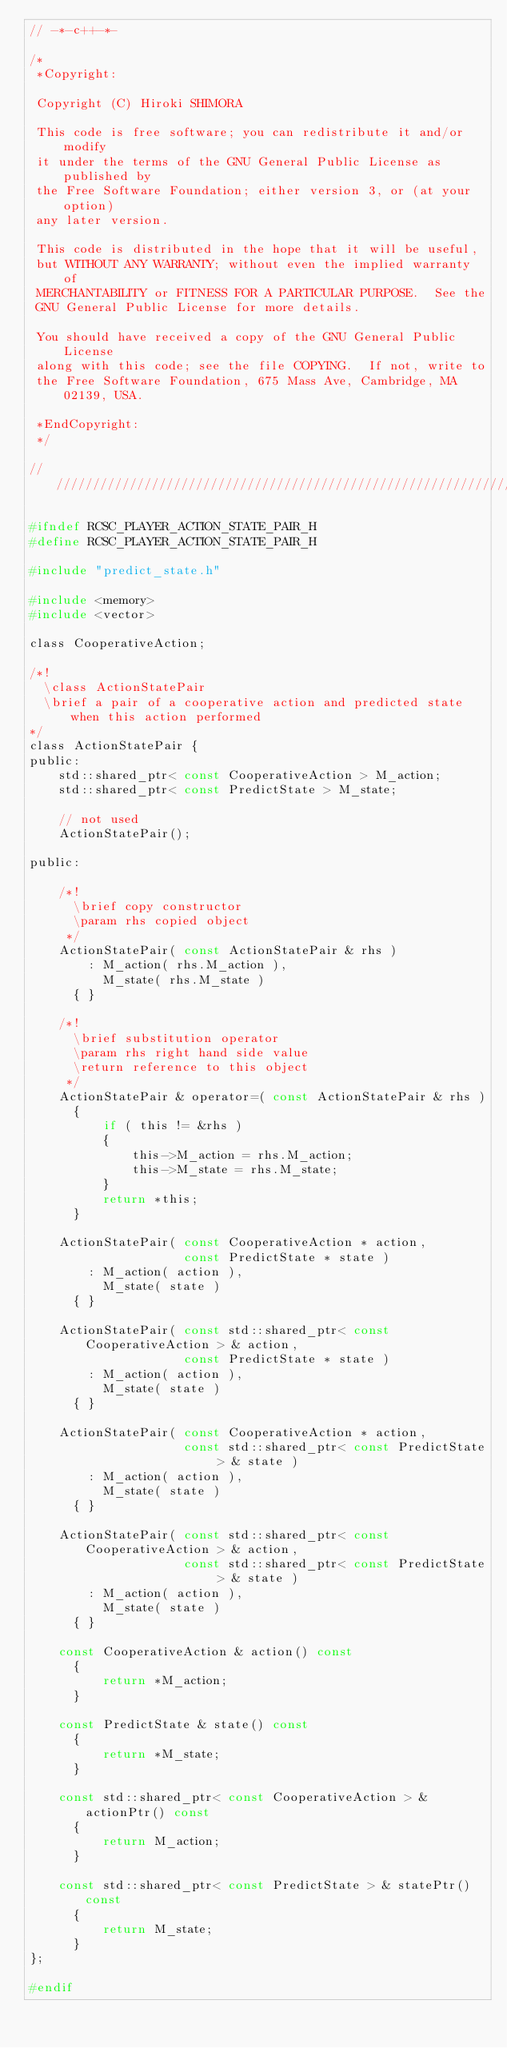<code> <loc_0><loc_0><loc_500><loc_500><_C_>// -*-c++-*-

/*
 *Copyright:

 Copyright (C) Hiroki SHIMORA

 This code is free software; you can redistribute it and/or modify
 it under the terms of the GNU General Public License as published by
 the Free Software Foundation; either version 3, or (at your option)
 any later version.

 This code is distributed in the hope that it will be useful,
 but WITHOUT ANY WARRANTY; without even the implied warranty of
 MERCHANTABILITY or FITNESS FOR A PARTICULAR PURPOSE.  See the
 GNU General Public License for more details.

 You should have received a copy of the GNU General Public License
 along with this code; see the file COPYING.  If not, write to
 the Free Software Foundation, 675 Mass Ave, Cambridge, MA 02139, USA.

 *EndCopyright:
 */

/////////////////////////////////////////////////////////////////////

#ifndef RCSC_PLAYER_ACTION_STATE_PAIR_H
#define RCSC_PLAYER_ACTION_STATE_PAIR_H

#include "predict_state.h"

#include <memory>
#include <vector>

class CooperativeAction;

/*!
  \class ActionStatePair
  \brief a pair of a cooperative action and predicted state when this action performed
*/
class ActionStatePair {
public:
    std::shared_ptr< const CooperativeAction > M_action;
    std::shared_ptr< const PredictState > M_state;

    // not used
    ActionStatePair();

public:

    /*!
      \brief copy constructor
      \param rhs copied object
     */
    ActionStatePair( const ActionStatePair & rhs )
        : M_action( rhs.M_action ),
          M_state( rhs.M_state )
      { }

    /*!
      \brief substitution operator
      \param rhs right hand side value
      \return reference to this object
     */
    ActionStatePair & operator=( const ActionStatePair & rhs )
      {
          if ( this != &rhs )
          {
              this->M_action = rhs.M_action;
              this->M_state = rhs.M_state;
          }
          return *this;
      }

    ActionStatePair( const CooperativeAction * action,
                     const PredictState * state )
        : M_action( action ),
          M_state( state )
      { }

    ActionStatePair( const std::shared_ptr< const CooperativeAction > & action,
                     const PredictState * state )
        : M_action( action ),
          M_state( state )
      { }

    ActionStatePair( const CooperativeAction * action,
                     const std::shared_ptr< const PredictState > & state )
        : M_action( action ),
          M_state( state )
      { }

    ActionStatePair( const std::shared_ptr< const CooperativeAction > & action,
                     const std::shared_ptr< const PredictState > & state )
        : M_action( action ),
          M_state( state )
      { }

    const CooperativeAction & action() const
      {
          return *M_action;
      }

    const PredictState & state() const
      {
          return *M_state;
      }

    const std::shared_ptr< const CooperativeAction > & actionPtr() const
      {
          return M_action;
      }

    const std::shared_ptr< const PredictState > & statePtr() const
      {
          return M_state;
      }
};

#endif
</code> 